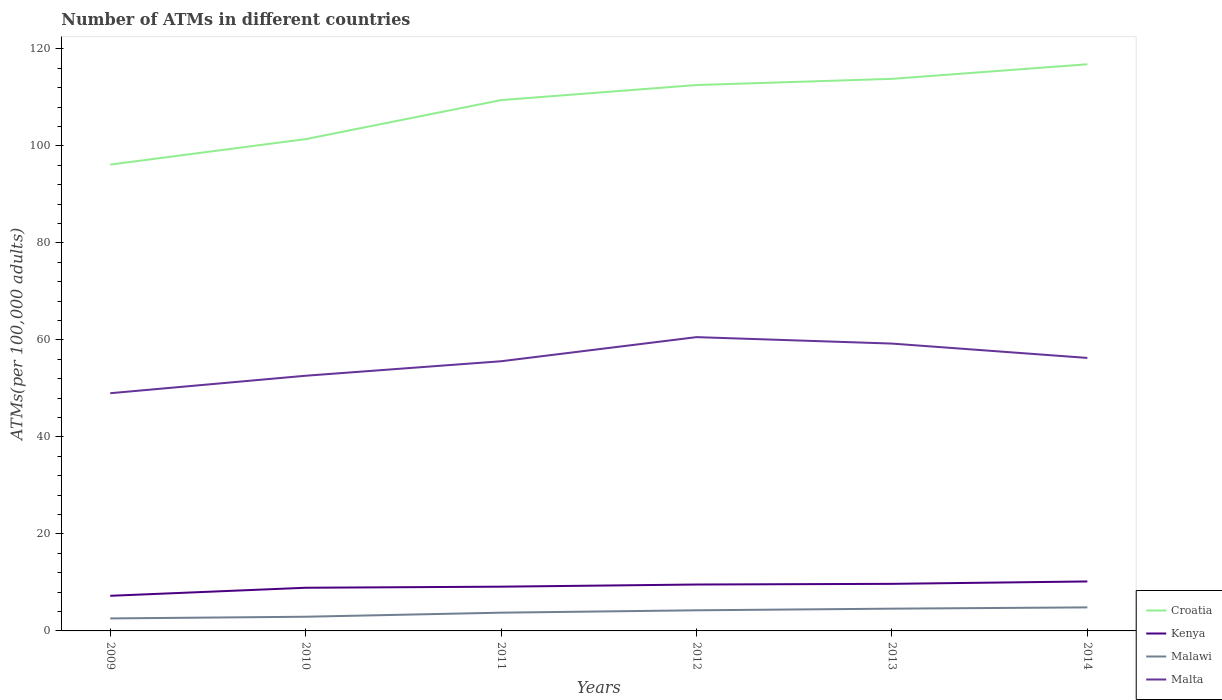Does the line corresponding to Kenya intersect with the line corresponding to Croatia?
Ensure brevity in your answer.  No. Across all years, what is the maximum number of ATMs in Croatia?
Your answer should be compact. 96.14. What is the total number of ATMs in Malawi in the graph?
Make the answer very short. -1.18. What is the difference between the highest and the second highest number of ATMs in Malta?
Keep it short and to the point. 11.56. Is the number of ATMs in Croatia strictly greater than the number of ATMs in Malawi over the years?
Provide a short and direct response. No. How many years are there in the graph?
Make the answer very short. 6. Are the values on the major ticks of Y-axis written in scientific E-notation?
Give a very brief answer. No. Does the graph contain grids?
Offer a terse response. No. How many legend labels are there?
Provide a succinct answer. 4. What is the title of the graph?
Provide a short and direct response. Number of ATMs in different countries. Does "South Sudan" appear as one of the legend labels in the graph?
Make the answer very short. No. What is the label or title of the Y-axis?
Your response must be concise. ATMs(per 100,0 adults). What is the ATMs(per 100,000 adults) in Croatia in 2009?
Your answer should be compact. 96.14. What is the ATMs(per 100,000 adults) of Kenya in 2009?
Offer a very short reply. 7.24. What is the ATMs(per 100,000 adults) in Malawi in 2009?
Keep it short and to the point. 2.58. What is the ATMs(per 100,000 adults) in Malta in 2009?
Offer a very short reply. 49.01. What is the ATMs(per 100,000 adults) in Croatia in 2010?
Give a very brief answer. 101.39. What is the ATMs(per 100,000 adults) of Kenya in 2010?
Provide a succinct answer. 8.9. What is the ATMs(per 100,000 adults) of Malawi in 2010?
Offer a terse response. 2.93. What is the ATMs(per 100,000 adults) of Malta in 2010?
Ensure brevity in your answer.  52.61. What is the ATMs(per 100,000 adults) of Croatia in 2011?
Make the answer very short. 109.44. What is the ATMs(per 100,000 adults) of Kenya in 2011?
Provide a short and direct response. 9.12. What is the ATMs(per 100,000 adults) of Malawi in 2011?
Provide a short and direct response. 3.76. What is the ATMs(per 100,000 adults) of Malta in 2011?
Provide a short and direct response. 55.6. What is the ATMs(per 100,000 adults) of Croatia in 2012?
Provide a short and direct response. 112.54. What is the ATMs(per 100,000 adults) in Kenya in 2012?
Give a very brief answer. 9.57. What is the ATMs(per 100,000 adults) of Malawi in 2012?
Give a very brief answer. 4.25. What is the ATMs(per 100,000 adults) of Malta in 2012?
Provide a succinct answer. 60.57. What is the ATMs(per 100,000 adults) of Croatia in 2013?
Keep it short and to the point. 113.82. What is the ATMs(per 100,000 adults) in Kenya in 2013?
Your answer should be very brief. 9.71. What is the ATMs(per 100,000 adults) of Malawi in 2013?
Ensure brevity in your answer.  4.59. What is the ATMs(per 100,000 adults) of Malta in 2013?
Provide a succinct answer. 59.24. What is the ATMs(per 100,000 adults) in Croatia in 2014?
Your response must be concise. 116.82. What is the ATMs(per 100,000 adults) of Kenya in 2014?
Your response must be concise. 10.2. What is the ATMs(per 100,000 adults) of Malawi in 2014?
Your answer should be compact. 4.85. What is the ATMs(per 100,000 adults) of Malta in 2014?
Keep it short and to the point. 56.28. Across all years, what is the maximum ATMs(per 100,000 adults) in Croatia?
Keep it short and to the point. 116.82. Across all years, what is the maximum ATMs(per 100,000 adults) of Kenya?
Your response must be concise. 10.2. Across all years, what is the maximum ATMs(per 100,000 adults) of Malawi?
Make the answer very short. 4.85. Across all years, what is the maximum ATMs(per 100,000 adults) of Malta?
Provide a short and direct response. 60.57. Across all years, what is the minimum ATMs(per 100,000 adults) of Croatia?
Provide a succinct answer. 96.14. Across all years, what is the minimum ATMs(per 100,000 adults) of Kenya?
Make the answer very short. 7.24. Across all years, what is the minimum ATMs(per 100,000 adults) of Malawi?
Your response must be concise. 2.58. Across all years, what is the minimum ATMs(per 100,000 adults) in Malta?
Give a very brief answer. 49.01. What is the total ATMs(per 100,000 adults) of Croatia in the graph?
Make the answer very short. 650.14. What is the total ATMs(per 100,000 adults) in Kenya in the graph?
Your answer should be very brief. 54.73. What is the total ATMs(per 100,000 adults) of Malawi in the graph?
Provide a short and direct response. 22.96. What is the total ATMs(per 100,000 adults) of Malta in the graph?
Ensure brevity in your answer.  333.3. What is the difference between the ATMs(per 100,000 adults) in Croatia in 2009 and that in 2010?
Make the answer very short. -5.25. What is the difference between the ATMs(per 100,000 adults) in Kenya in 2009 and that in 2010?
Provide a succinct answer. -1.66. What is the difference between the ATMs(per 100,000 adults) in Malawi in 2009 and that in 2010?
Provide a short and direct response. -0.35. What is the difference between the ATMs(per 100,000 adults) of Malta in 2009 and that in 2010?
Ensure brevity in your answer.  -3.6. What is the difference between the ATMs(per 100,000 adults) of Croatia in 2009 and that in 2011?
Offer a terse response. -13.3. What is the difference between the ATMs(per 100,000 adults) in Kenya in 2009 and that in 2011?
Your response must be concise. -1.88. What is the difference between the ATMs(per 100,000 adults) in Malawi in 2009 and that in 2011?
Give a very brief answer. -1.18. What is the difference between the ATMs(per 100,000 adults) in Malta in 2009 and that in 2011?
Ensure brevity in your answer.  -6.59. What is the difference between the ATMs(per 100,000 adults) in Croatia in 2009 and that in 2012?
Provide a short and direct response. -16.4. What is the difference between the ATMs(per 100,000 adults) in Kenya in 2009 and that in 2012?
Keep it short and to the point. -2.33. What is the difference between the ATMs(per 100,000 adults) of Malawi in 2009 and that in 2012?
Your answer should be compact. -1.68. What is the difference between the ATMs(per 100,000 adults) in Malta in 2009 and that in 2012?
Offer a terse response. -11.56. What is the difference between the ATMs(per 100,000 adults) of Croatia in 2009 and that in 2013?
Ensure brevity in your answer.  -17.68. What is the difference between the ATMs(per 100,000 adults) of Kenya in 2009 and that in 2013?
Make the answer very short. -2.46. What is the difference between the ATMs(per 100,000 adults) of Malawi in 2009 and that in 2013?
Ensure brevity in your answer.  -2.01. What is the difference between the ATMs(per 100,000 adults) of Malta in 2009 and that in 2013?
Offer a very short reply. -10.23. What is the difference between the ATMs(per 100,000 adults) in Croatia in 2009 and that in 2014?
Keep it short and to the point. -20.68. What is the difference between the ATMs(per 100,000 adults) of Kenya in 2009 and that in 2014?
Offer a terse response. -2.96. What is the difference between the ATMs(per 100,000 adults) in Malawi in 2009 and that in 2014?
Keep it short and to the point. -2.28. What is the difference between the ATMs(per 100,000 adults) of Malta in 2009 and that in 2014?
Keep it short and to the point. -7.27. What is the difference between the ATMs(per 100,000 adults) of Croatia in 2010 and that in 2011?
Ensure brevity in your answer.  -8.05. What is the difference between the ATMs(per 100,000 adults) of Kenya in 2010 and that in 2011?
Offer a very short reply. -0.22. What is the difference between the ATMs(per 100,000 adults) of Malawi in 2010 and that in 2011?
Provide a short and direct response. -0.84. What is the difference between the ATMs(per 100,000 adults) of Malta in 2010 and that in 2011?
Provide a short and direct response. -2.99. What is the difference between the ATMs(per 100,000 adults) of Croatia in 2010 and that in 2012?
Make the answer very short. -11.15. What is the difference between the ATMs(per 100,000 adults) of Kenya in 2010 and that in 2012?
Give a very brief answer. -0.67. What is the difference between the ATMs(per 100,000 adults) of Malawi in 2010 and that in 2012?
Offer a very short reply. -1.33. What is the difference between the ATMs(per 100,000 adults) of Malta in 2010 and that in 2012?
Keep it short and to the point. -7.96. What is the difference between the ATMs(per 100,000 adults) in Croatia in 2010 and that in 2013?
Keep it short and to the point. -12.43. What is the difference between the ATMs(per 100,000 adults) in Kenya in 2010 and that in 2013?
Give a very brief answer. -0.81. What is the difference between the ATMs(per 100,000 adults) in Malawi in 2010 and that in 2013?
Provide a succinct answer. -1.67. What is the difference between the ATMs(per 100,000 adults) in Malta in 2010 and that in 2013?
Your response must be concise. -6.63. What is the difference between the ATMs(per 100,000 adults) of Croatia in 2010 and that in 2014?
Ensure brevity in your answer.  -15.43. What is the difference between the ATMs(per 100,000 adults) of Kenya in 2010 and that in 2014?
Make the answer very short. -1.3. What is the difference between the ATMs(per 100,000 adults) in Malawi in 2010 and that in 2014?
Provide a short and direct response. -1.93. What is the difference between the ATMs(per 100,000 adults) of Malta in 2010 and that in 2014?
Your answer should be very brief. -3.67. What is the difference between the ATMs(per 100,000 adults) of Croatia in 2011 and that in 2012?
Offer a terse response. -3.1. What is the difference between the ATMs(per 100,000 adults) of Kenya in 2011 and that in 2012?
Your answer should be compact. -0.45. What is the difference between the ATMs(per 100,000 adults) of Malawi in 2011 and that in 2012?
Provide a short and direct response. -0.49. What is the difference between the ATMs(per 100,000 adults) of Malta in 2011 and that in 2012?
Offer a very short reply. -4.97. What is the difference between the ATMs(per 100,000 adults) of Croatia in 2011 and that in 2013?
Ensure brevity in your answer.  -4.38. What is the difference between the ATMs(per 100,000 adults) in Kenya in 2011 and that in 2013?
Make the answer very short. -0.58. What is the difference between the ATMs(per 100,000 adults) of Malawi in 2011 and that in 2013?
Provide a short and direct response. -0.83. What is the difference between the ATMs(per 100,000 adults) in Malta in 2011 and that in 2013?
Provide a short and direct response. -3.64. What is the difference between the ATMs(per 100,000 adults) of Croatia in 2011 and that in 2014?
Your response must be concise. -7.38. What is the difference between the ATMs(per 100,000 adults) in Kenya in 2011 and that in 2014?
Offer a very short reply. -1.08. What is the difference between the ATMs(per 100,000 adults) of Malawi in 2011 and that in 2014?
Your response must be concise. -1.09. What is the difference between the ATMs(per 100,000 adults) in Malta in 2011 and that in 2014?
Provide a succinct answer. -0.68. What is the difference between the ATMs(per 100,000 adults) of Croatia in 2012 and that in 2013?
Make the answer very short. -1.28. What is the difference between the ATMs(per 100,000 adults) in Kenya in 2012 and that in 2013?
Provide a short and direct response. -0.14. What is the difference between the ATMs(per 100,000 adults) of Malawi in 2012 and that in 2013?
Your answer should be very brief. -0.34. What is the difference between the ATMs(per 100,000 adults) of Malta in 2012 and that in 2013?
Your answer should be very brief. 1.33. What is the difference between the ATMs(per 100,000 adults) of Croatia in 2012 and that in 2014?
Offer a terse response. -4.28. What is the difference between the ATMs(per 100,000 adults) of Kenya in 2012 and that in 2014?
Ensure brevity in your answer.  -0.63. What is the difference between the ATMs(per 100,000 adults) in Malawi in 2012 and that in 2014?
Provide a succinct answer. -0.6. What is the difference between the ATMs(per 100,000 adults) of Malta in 2012 and that in 2014?
Offer a terse response. 4.29. What is the difference between the ATMs(per 100,000 adults) in Croatia in 2013 and that in 2014?
Provide a short and direct response. -3. What is the difference between the ATMs(per 100,000 adults) in Kenya in 2013 and that in 2014?
Make the answer very short. -0.49. What is the difference between the ATMs(per 100,000 adults) of Malawi in 2013 and that in 2014?
Give a very brief answer. -0.26. What is the difference between the ATMs(per 100,000 adults) in Malta in 2013 and that in 2014?
Provide a succinct answer. 2.96. What is the difference between the ATMs(per 100,000 adults) of Croatia in 2009 and the ATMs(per 100,000 adults) of Kenya in 2010?
Provide a succinct answer. 87.24. What is the difference between the ATMs(per 100,000 adults) in Croatia in 2009 and the ATMs(per 100,000 adults) in Malawi in 2010?
Your response must be concise. 93.21. What is the difference between the ATMs(per 100,000 adults) of Croatia in 2009 and the ATMs(per 100,000 adults) of Malta in 2010?
Offer a terse response. 43.53. What is the difference between the ATMs(per 100,000 adults) in Kenya in 2009 and the ATMs(per 100,000 adults) in Malawi in 2010?
Offer a terse response. 4.32. What is the difference between the ATMs(per 100,000 adults) of Kenya in 2009 and the ATMs(per 100,000 adults) of Malta in 2010?
Offer a very short reply. -45.37. What is the difference between the ATMs(per 100,000 adults) in Malawi in 2009 and the ATMs(per 100,000 adults) in Malta in 2010?
Your answer should be very brief. -50.03. What is the difference between the ATMs(per 100,000 adults) of Croatia in 2009 and the ATMs(per 100,000 adults) of Kenya in 2011?
Offer a terse response. 87.02. What is the difference between the ATMs(per 100,000 adults) of Croatia in 2009 and the ATMs(per 100,000 adults) of Malawi in 2011?
Offer a terse response. 92.38. What is the difference between the ATMs(per 100,000 adults) of Croatia in 2009 and the ATMs(per 100,000 adults) of Malta in 2011?
Offer a terse response. 40.54. What is the difference between the ATMs(per 100,000 adults) of Kenya in 2009 and the ATMs(per 100,000 adults) of Malawi in 2011?
Give a very brief answer. 3.48. What is the difference between the ATMs(per 100,000 adults) in Kenya in 2009 and the ATMs(per 100,000 adults) in Malta in 2011?
Make the answer very short. -48.36. What is the difference between the ATMs(per 100,000 adults) in Malawi in 2009 and the ATMs(per 100,000 adults) in Malta in 2011?
Your answer should be compact. -53.02. What is the difference between the ATMs(per 100,000 adults) in Croatia in 2009 and the ATMs(per 100,000 adults) in Kenya in 2012?
Your response must be concise. 86.57. What is the difference between the ATMs(per 100,000 adults) of Croatia in 2009 and the ATMs(per 100,000 adults) of Malawi in 2012?
Your response must be concise. 91.89. What is the difference between the ATMs(per 100,000 adults) in Croatia in 2009 and the ATMs(per 100,000 adults) in Malta in 2012?
Your answer should be very brief. 35.57. What is the difference between the ATMs(per 100,000 adults) in Kenya in 2009 and the ATMs(per 100,000 adults) in Malawi in 2012?
Ensure brevity in your answer.  2.99. What is the difference between the ATMs(per 100,000 adults) in Kenya in 2009 and the ATMs(per 100,000 adults) in Malta in 2012?
Provide a succinct answer. -53.33. What is the difference between the ATMs(per 100,000 adults) of Malawi in 2009 and the ATMs(per 100,000 adults) of Malta in 2012?
Provide a succinct answer. -57.99. What is the difference between the ATMs(per 100,000 adults) in Croatia in 2009 and the ATMs(per 100,000 adults) in Kenya in 2013?
Your answer should be very brief. 86.43. What is the difference between the ATMs(per 100,000 adults) of Croatia in 2009 and the ATMs(per 100,000 adults) of Malawi in 2013?
Give a very brief answer. 91.55. What is the difference between the ATMs(per 100,000 adults) of Croatia in 2009 and the ATMs(per 100,000 adults) of Malta in 2013?
Offer a very short reply. 36.9. What is the difference between the ATMs(per 100,000 adults) in Kenya in 2009 and the ATMs(per 100,000 adults) in Malawi in 2013?
Offer a terse response. 2.65. What is the difference between the ATMs(per 100,000 adults) in Kenya in 2009 and the ATMs(per 100,000 adults) in Malta in 2013?
Keep it short and to the point. -52. What is the difference between the ATMs(per 100,000 adults) in Malawi in 2009 and the ATMs(per 100,000 adults) in Malta in 2013?
Your answer should be very brief. -56.66. What is the difference between the ATMs(per 100,000 adults) of Croatia in 2009 and the ATMs(per 100,000 adults) of Kenya in 2014?
Keep it short and to the point. 85.94. What is the difference between the ATMs(per 100,000 adults) in Croatia in 2009 and the ATMs(per 100,000 adults) in Malawi in 2014?
Provide a short and direct response. 91.29. What is the difference between the ATMs(per 100,000 adults) of Croatia in 2009 and the ATMs(per 100,000 adults) of Malta in 2014?
Ensure brevity in your answer.  39.86. What is the difference between the ATMs(per 100,000 adults) in Kenya in 2009 and the ATMs(per 100,000 adults) in Malawi in 2014?
Your response must be concise. 2.39. What is the difference between the ATMs(per 100,000 adults) of Kenya in 2009 and the ATMs(per 100,000 adults) of Malta in 2014?
Offer a very short reply. -49.04. What is the difference between the ATMs(per 100,000 adults) in Malawi in 2009 and the ATMs(per 100,000 adults) in Malta in 2014?
Your answer should be very brief. -53.71. What is the difference between the ATMs(per 100,000 adults) of Croatia in 2010 and the ATMs(per 100,000 adults) of Kenya in 2011?
Keep it short and to the point. 92.27. What is the difference between the ATMs(per 100,000 adults) in Croatia in 2010 and the ATMs(per 100,000 adults) in Malawi in 2011?
Offer a terse response. 97.63. What is the difference between the ATMs(per 100,000 adults) of Croatia in 2010 and the ATMs(per 100,000 adults) of Malta in 2011?
Your answer should be very brief. 45.79. What is the difference between the ATMs(per 100,000 adults) in Kenya in 2010 and the ATMs(per 100,000 adults) in Malawi in 2011?
Provide a short and direct response. 5.14. What is the difference between the ATMs(per 100,000 adults) of Kenya in 2010 and the ATMs(per 100,000 adults) of Malta in 2011?
Provide a short and direct response. -46.7. What is the difference between the ATMs(per 100,000 adults) of Malawi in 2010 and the ATMs(per 100,000 adults) of Malta in 2011?
Ensure brevity in your answer.  -52.67. What is the difference between the ATMs(per 100,000 adults) of Croatia in 2010 and the ATMs(per 100,000 adults) of Kenya in 2012?
Keep it short and to the point. 91.82. What is the difference between the ATMs(per 100,000 adults) of Croatia in 2010 and the ATMs(per 100,000 adults) of Malawi in 2012?
Provide a short and direct response. 97.14. What is the difference between the ATMs(per 100,000 adults) of Croatia in 2010 and the ATMs(per 100,000 adults) of Malta in 2012?
Ensure brevity in your answer.  40.82. What is the difference between the ATMs(per 100,000 adults) of Kenya in 2010 and the ATMs(per 100,000 adults) of Malawi in 2012?
Provide a succinct answer. 4.65. What is the difference between the ATMs(per 100,000 adults) in Kenya in 2010 and the ATMs(per 100,000 adults) in Malta in 2012?
Your answer should be compact. -51.67. What is the difference between the ATMs(per 100,000 adults) of Malawi in 2010 and the ATMs(per 100,000 adults) of Malta in 2012?
Make the answer very short. -57.64. What is the difference between the ATMs(per 100,000 adults) of Croatia in 2010 and the ATMs(per 100,000 adults) of Kenya in 2013?
Ensure brevity in your answer.  91.68. What is the difference between the ATMs(per 100,000 adults) of Croatia in 2010 and the ATMs(per 100,000 adults) of Malawi in 2013?
Provide a short and direct response. 96.8. What is the difference between the ATMs(per 100,000 adults) in Croatia in 2010 and the ATMs(per 100,000 adults) in Malta in 2013?
Your response must be concise. 42.15. What is the difference between the ATMs(per 100,000 adults) in Kenya in 2010 and the ATMs(per 100,000 adults) in Malawi in 2013?
Offer a very short reply. 4.31. What is the difference between the ATMs(per 100,000 adults) in Kenya in 2010 and the ATMs(per 100,000 adults) in Malta in 2013?
Ensure brevity in your answer.  -50.34. What is the difference between the ATMs(per 100,000 adults) in Malawi in 2010 and the ATMs(per 100,000 adults) in Malta in 2013?
Keep it short and to the point. -56.31. What is the difference between the ATMs(per 100,000 adults) in Croatia in 2010 and the ATMs(per 100,000 adults) in Kenya in 2014?
Keep it short and to the point. 91.19. What is the difference between the ATMs(per 100,000 adults) of Croatia in 2010 and the ATMs(per 100,000 adults) of Malawi in 2014?
Offer a very short reply. 96.54. What is the difference between the ATMs(per 100,000 adults) in Croatia in 2010 and the ATMs(per 100,000 adults) in Malta in 2014?
Ensure brevity in your answer.  45.11. What is the difference between the ATMs(per 100,000 adults) of Kenya in 2010 and the ATMs(per 100,000 adults) of Malawi in 2014?
Ensure brevity in your answer.  4.05. What is the difference between the ATMs(per 100,000 adults) of Kenya in 2010 and the ATMs(per 100,000 adults) of Malta in 2014?
Provide a short and direct response. -47.38. What is the difference between the ATMs(per 100,000 adults) of Malawi in 2010 and the ATMs(per 100,000 adults) of Malta in 2014?
Your response must be concise. -53.36. What is the difference between the ATMs(per 100,000 adults) in Croatia in 2011 and the ATMs(per 100,000 adults) in Kenya in 2012?
Keep it short and to the point. 99.87. What is the difference between the ATMs(per 100,000 adults) of Croatia in 2011 and the ATMs(per 100,000 adults) of Malawi in 2012?
Ensure brevity in your answer.  105.18. What is the difference between the ATMs(per 100,000 adults) of Croatia in 2011 and the ATMs(per 100,000 adults) of Malta in 2012?
Offer a terse response. 48.87. What is the difference between the ATMs(per 100,000 adults) of Kenya in 2011 and the ATMs(per 100,000 adults) of Malawi in 2012?
Keep it short and to the point. 4.87. What is the difference between the ATMs(per 100,000 adults) of Kenya in 2011 and the ATMs(per 100,000 adults) of Malta in 2012?
Make the answer very short. -51.45. What is the difference between the ATMs(per 100,000 adults) of Malawi in 2011 and the ATMs(per 100,000 adults) of Malta in 2012?
Offer a terse response. -56.81. What is the difference between the ATMs(per 100,000 adults) in Croatia in 2011 and the ATMs(per 100,000 adults) in Kenya in 2013?
Offer a terse response. 99.73. What is the difference between the ATMs(per 100,000 adults) in Croatia in 2011 and the ATMs(per 100,000 adults) in Malawi in 2013?
Your answer should be compact. 104.85. What is the difference between the ATMs(per 100,000 adults) in Croatia in 2011 and the ATMs(per 100,000 adults) in Malta in 2013?
Provide a succinct answer. 50.2. What is the difference between the ATMs(per 100,000 adults) of Kenya in 2011 and the ATMs(per 100,000 adults) of Malawi in 2013?
Offer a very short reply. 4.53. What is the difference between the ATMs(per 100,000 adults) in Kenya in 2011 and the ATMs(per 100,000 adults) in Malta in 2013?
Your answer should be very brief. -50.12. What is the difference between the ATMs(per 100,000 adults) in Malawi in 2011 and the ATMs(per 100,000 adults) in Malta in 2013?
Your answer should be compact. -55.48. What is the difference between the ATMs(per 100,000 adults) of Croatia in 2011 and the ATMs(per 100,000 adults) of Kenya in 2014?
Give a very brief answer. 99.24. What is the difference between the ATMs(per 100,000 adults) in Croatia in 2011 and the ATMs(per 100,000 adults) in Malawi in 2014?
Give a very brief answer. 104.58. What is the difference between the ATMs(per 100,000 adults) of Croatia in 2011 and the ATMs(per 100,000 adults) of Malta in 2014?
Provide a succinct answer. 53.15. What is the difference between the ATMs(per 100,000 adults) of Kenya in 2011 and the ATMs(per 100,000 adults) of Malawi in 2014?
Your answer should be very brief. 4.27. What is the difference between the ATMs(per 100,000 adults) in Kenya in 2011 and the ATMs(per 100,000 adults) in Malta in 2014?
Offer a very short reply. -47.16. What is the difference between the ATMs(per 100,000 adults) in Malawi in 2011 and the ATMs(per 100,000 adults) in Malta in 2014?
Ensure brevity in your answer.  -52.52. What is the difference between the ATMs(per 100,000 adults) of Croatia in 2012 and the ATMs(per 100,000 adults) of Kenya in 2013?
Ensure brevity in your answer.  102.83. What is the difference between the ATMs(per 100,000 adults) in Croatia in 2012 and the ATMs(per 100,000 adults) in Malawi in 2013?
Your answer should be very brief. 107.95. What is the difference between the ATMs(per 100,000 adults) in Croatia in 2012 and the ATMs(per 100,000 adults) in Malta in 2013?
Offer a very short reply. 53.3. What is the difference between the ATMs(per 100,000 adults) in Kenya in 2012 and the ATMs(per 100,000 adults) in Malawi in 2013?
Ensure brevity in your answer.  4.98. What is the difference between the ATMs(per 100,000 adults) of Kenya in 2012 and the ATMs(per 100,000 adults) of Malta in 2013?
Your answer should be very brief. -49.67. What is the difference between the ATMs(per 100,000 adults) of Malawi in 2012 and the ATMs(per 100,000 adults) of Malta in 2013?
Offer a terse response. -54.99. What is the difference between the ATMs(per 100,000 adults) of Croatia in 2012 and the ATMs(per 100,000 adults) of Kenya in 2014?
Your answer should be compact. 102.34. What is the difference between the ATMs(per 100,000 adults) of Croatia in 2012 and the ATMs(per 100,000 adults) of Malawi in 2014?
Your answer should be very brief. 107.69. What is the difference between the ATMs(per 100,000 adults) of Croatia in 2012 and the ATMs(per 100,000 adults) of Malta in 2014?
Offer a terse response. 56.26. What is the difference between the ATMs(per 100,000 adults) in Kenya in 2012 and the ATMs(per 100,000 adults) in Malawi in 2014?
Your answer should be compact. 4.72. What is the difference between the ATMs(per 100,000 adults) of Kenya in 2012 and the ATMs(per 100,000 adults) of Malta in 2014?
Provide a short and direct response. -46.71. What is the difference between the ATMs(per 100,000 adults) in Malawi in 2012 and the ATMs(per 100,000 adults) in Malta in 2014?
Your answer should be compact. -52.03. What is the difference between the ATMs(per 100,000 adults) of Croatia in 2013 and the ATMs(per 100,000 adults) of Kenya in 2014?
Make the answer very short. 103.62. What is the difference between the ATMs(per 100,000 adults) in Croatia in 2013 and the ATMs(per 100,000 adults) in Malawi in 2014?
Give a very brief answer. 108.97. What is the difference between the ATMs(per 100,000 adults) in Croatia in 2013 and the ATMs(per 100,000 adults) in Malta in 2014?
Your response must be concise. 57.54. What is the difference between the ATMs(per 100,000 adults) in Kenya in 2013 and the ATMs(per 100,000 adults) in Malawi in 2014?
Offer a terse response. 4.85. What is the difference between the ATMs(per 100,000 adults) in Kenya in 2013 and the ATMs(per 100,000 adults) in Malta in 2014?
Offer a very short reply. -46.58. What is the difference between the ATMs(per 100,000 adults) of Malawi in 2013 and the ATMs(per 100,000 adults) of Malta in 2014?
Provide a succinct answer. -51.69. What is the average ATMs(per 100,000 adults) of Croatia per year?
Keep it short and to the point. 108.36. What is the average ATMs(per 100,000 adults) of Kenya per year?
Make the answer very short. 9.12. What is the average ATMs(per 100,000 adults) of Malawi per year?
Give a very brief answer. 3.83. What is the average ATMs(per 100,000 adults) of Malta per year?
Ensure brevity in your answer.  55.55. In the year 2009, what is the difference between the ATMs(per 100,000 adults) of Croatia and ATMs(per 100,000 adults) of Kenya?
Offer a very short reply. 88.9. In the year 2009, what is the difference between the ATMs(per 100,000 adults) of Croatia and ATMs(per 100,000 adults) of Malawi?
Your answer should be compact. 93.56. In the year 2009, what is the difference between the ATMs(per 100,000 adults) in Croatia and ATMs(per 100,000 adults) in Malta?
Make the answer very short. 47.13. In the year 2009, what is the difference between the ATMs(per 100,000 adults) of Kenya and ATMs(per 100,000 adults) of Malawi?
Ensure brevity in your answer.  4.67. In the year 2009, what is the difference between the ATMs(per 100,000 adults) in Kenya and ATMs(per 100,000 adults) in Malta?
Keep it short and to the point. -41.77. In the year 2009, what is the difference between the ATMs(per 100,000 adults) in Malawi and ATMs(per 100,000 adults) in Malta?
Provide a short and direct response. -46.43. In the year 2010, what is the difference between the ATMs(per 100,000 adults) in Croatia and ATMs(per 100,000 adults) in Kenya?
Offer a terse response. 92.49. In the year 2010, what is the difference between the ATMs(per 100,000 adults) in Croatia and ATMs(per 100,000 adults) in Malawi?
Provide a short and direct response. 98.46. In the year 2010, what is the difference between the ATMs(per 100,000 adults) in Croatia and ATMs(per 100,000 adults) in Malta?
Provide a short and direct response. 48.78. In the year 2010, what is the difference between the ATMs(per 100,000 adults) of Kenya and ATMs(per 100,000 adults) of Malawi?
Provide a succinct answer. 5.97. In the year 2010, what is the difference between the ATMs(per 100,000 adults) of Kenya and ATMs(per 100,000 adults) of Malta?
Your answer should be compact. -43.71. In the year 2010, what is the difference between the ATMs(per 100,000 adults) of Malawi and ATMs(per 100,000 adults) of Malta?
Your response must be concise. -49.68. In the year 2011, what is the difference between the ATMs(per 100,000 adults) of Croatia and ATMs(per 100,000 adults) of Kenya?
Offer a terse response. 100.31. In the year 2011, what is the difference between the ATMs(per 100,000 adults) of Croatia and ATMs(per 100,000 adults) of Malawi?
Provide a succinct answer. 105.68. In the year 2011, what is the difference between the ATMs(per 100,000 adults) of Croatia and ATMs(per 100,000 adults) of Malta?
Provide a succinct answer. 53.84. In the year 2011, what is the difference between the ATMs(per 100,000 adults) of Kenya and ATMs(per 100,000 adults) of Malawi?
Provide a short and direct response. 5.36. In the year 2011, what is the difference between the ATMs(per 100,000 adults) in Kenya and ATMs(per 100,000 adults) in Malta?
Provide a succinct answer. -46.48. In the year 2011, what is the difference between the ATMs(per 100,000 adults) of Malawi and ATMs(per 100,000 adults) of Malta?
Your response must be concise. -51.84. In the year 2012, what is the difference between the ATMs(per 100,000 adults) of Croatia and ATMs(per 100,000 adults) of Kenya?
Give a very brief answer. 102.97. In the year 2012, what is the difference between the ATMs(per 100,000 adults) of Croatia and ATMs(per 100,000 adults) of Malawi?
Provide a succinct answer. 108.29. In the year 2012, what is the difference between the ATMs(per 100,000 adults) of Croatia and ATMs(per 100,000 adults) of Malta?
Offer a terse response. 51.97. In the year 2012, what is the difference between the ATMs(per 100,000 adults) of Kenya and ATMs(per 100,000 adults) of Malawi?
Your response must be concise. 5.32. In the year 2012, what is the difference between the ATMs(per 100,000 adults) of Kenya and ATMs(per 100,000 adults) of Malta?
Provide a succinct answer. -51. In the year 2012, what is the difference between the ATMs(per 100,000 adults) in Malawi and ATMs(per 100,000 adults) in Malta?
Keep it short and to the point. -56.32. In the year 2013, what is the difference between the ATMs(per 100,000 adults) in Croatia and ATMs(per 100,000 adults) in Kenya?
Offer a terse response. 104.11. In the year 2013, what is the difference between the ATMs(per 100,000 adults) of Croatia and ATMs(per 100,000 adults) of Malawi?
Your answer should be very brief. 109.23. In the year 2013, what is the difference between the ATMs(per 100,000 adults) of Croatia and ATMs(per 100,000 adults) of Malta?
Provide a short and direct response. 54.58. In the year 2013, what is the difference between the ATMs(per 100,000 adults) in Kenya and ATMs(per 100,000 adults) in Malawi?
Your response must be concise. 5.11. In the year 2013, what is the difference between the ATMs(per 100,000 adults) in Kenya and ATMs(per 100,000 adults) in Malta?
Make the answer very short. -49.53. In the year 2013, what is the difference between the ATMs(per 100,000 adults) of Malawi and ATMs(per 100,000 adults) of Malta?
Provide a short and direct response. -54.65. In the year 2014, what is the difference between the ATMs(per 100,000 adults) of Croatia and ATMs(per 100,000 adults) of Kenya?
Ensure brevity in your answer.  106.62. In the year 2014, what is the difference between the ATMs(per 100,000 adults) of Croatia and ATMs(per 100,000 adults) of Malawi?
Offer a very short reply. 111.97. In the year 2014, what is the difference between the ATMs(per 100,000 adults) in Croatia and ATMs(per 100,000 adults) in Malta?
Offer a terse response. 60.54. In the year 2014, what is the difference between the ATMs(per 100,000 adults) of Kenya and ATMs(per 100,000 adults) of Malawi?
Ensure brevity in your answer.  5.34. In the year 2014, what is the difference between the ATMs(per 100,000 adults) in Kenya and ATMs(per 100,000 adults) in Malta?
Your answer should be very brief. -46.08. In the year 2014, what is the difference between the ATMs(per 100,000 adults) of Malawi and ATMs(per 100,000 adults) of Malta?
Your answer should be compact. -51.43. What is the ratio of the ATMs(per 100,000 adults) of Croatia in 2009 to that in 2010?
Provide a succinct answer. 0.95. What is the ratio of the ATMs(per 100,000 adults) in Kenya in 2009 to that in 2010?
Make the answer very short. 0.81. What is the ratio of the ATMs(per 100,000 adults) in Malawi in 2009 to that in 2010?
Ensure brevity in your answer.  0.88. What is the ratio of the ATMs(per 100,000 adults) in Malta in 2009 to that in 2010?
Offer a terse response. 0.93. What is the ratio of the ATMs(per 100,000 adults) of Croatia in 2009 to that in 2011?
Your answer should be very brief. 0.88. What is the ratio of the ATMs(per 100,000 adults) in Kenya in 2009 to that in 2011?
Offer a very short reply. 0.79. What is the ratio of the ATMs(per 100,000 adults) in Malawi in 2009 to that in 2011?
Offer a terse response. 0.69. What is the ratio of the ATMs(per 100,000 adults) in Malta in 2009 to that in 2011?
Your response must be concise. 0.88. What is the ratio of the ATMs(per 100,000 adults) of Croatia in 2009 to that in 2012?
Offer a terse response. 0.85. What is the ratio of the ATMs(per 100,000 adults) of Kenya in 2009 to that in 2012?
Provide a short and direct response. 0.76. What is the ratio of the ATMs(per 100,000 adults) of Malawi in 2009 to that in 2012?
Offer a terse response. 0.61. What is the ratio of the ATMs(per 100,000 adults) of Malta in 2009 to that in 2012?
Ensure brevity in your answer.  0.81. What is the ratio of the ATMs(per 100,000 adults) in Croatia in 2009 to that in 2013?
Give a very brief answer. 0.84. What is the ratio of the ATMs(per 100,000 adults) in Kenya in 2009 to that in 2013?
Provide a short and direct response. 0.75. What is the ratio of the ATMs(per 100,000 adults) in Malawi in 2009 to that in 2013?
Offer a very short reply. 0.56. What is the ratio of the ATMs(per 100,000 adults) in Malta in 2009 to that in 2013?
Your answer should be compact. 0.83. What is the ratio of the ATMs(per 100,000 adults) of Croatia in 2009 to that in 2014?
Ensure brevity in your answer.  0.82. What is the ratio of the ATMs(per 100,000 adults) in Kenya in 2009 to that in 2014?
Your answer should be very brief. 0.71. What is the ratio of the ATMs(per 100,000 adults) in Malawi in 2009 to that in 2014?
Your answer should be compact. 0.53. What is the ratio of the ATMs(per 100,000 adults) in Malta in 2009 to that in 2014?
Make the answer very short. 0.87. What is the ratio of the ATMs(per 100,000 adults) of Croatia in 2010 to that in 2011?
Make the answer very short. 0.93. What is the ratio of the ATMs(per 100,000 adults) in Kenya in 2010 to that in 2011?
Your response must be concise. 0.98. What is the ratio of the ATMs(per 100,000 adults) of Malta in 2010 to that in 2011?
Ensure brevity in your answer.  0.95. What is the ratio of the ATMs(per 100,000 adults) in Croatia in 2010 to that in 2012?
Make the answer very short. 0.9. What is the ratio of the ATMs(per 100,000 adults) of Kenya in 2010 to that in 2012?
Your answer should be compact. 0.93. What is the ratio of the ATMs(per 100,000 adults) in Malawi in 2010 to that in 2012?
Provide a succinct answer. 0.69. What is the ratio of the ATMs(per 100,000 adults) of Malta in 2010 to that in 2012?
Offer a very short reply. 0.87. What is the ratio of the ATMs(per 100,000 adults) in Croatia in 2010 to that in 2013?
Make the answer very short. 0.89. What is the ratio of the ATMs(per 100,000 adults) in Kenya in 2010 to that in 2013?
Your response must be concise. 0.92. What is the ratio of the ATMs(per 100,000 adults) in Malawi in 2010 to that in 2013?
Provide a short and direct response. 0.64. What is the ratio of the ATMs(per 100,000 adults) of Malta in 2010 to that in 2013?
Ensure brevity in your answer.  0.89. What is the ratio of the ATMs(per 100,000 adults) of Croatia in 2010 to that in 2014?
Provide a succinct answer. 0.87. What is the ratio of the ATMs(per 100,000 adults) of Kenya in 2010 to that in 2014?
Make the answer very short. 0.87. What is the ratio of the ATMs(per 100,000 adults) of Malawi in 2010 to that in 2014?
Your answer should be compact. 0.6. What is the ratio of the ATMs(per 100,000 adults) in Malta in 2010 to that in 2014?
Your answer should be very brief. 0.93. What is the ratio of the ATMs(per 100,000 adults) of Croatia in 2011 to that in 2012?
Your answer should be very brief. 0.97. What is the ratio of the ATMs(per 100,000 adults) of Kenya in 2011 to that in 2012?
Provide a short and direct response. 0.95. What is the ratio of the ATMs(per 100,000 adults) of Malawi in 2011 to that in 2012?
Give a very brief answer. 0.88. What is the ratio of the ATMs(per 100,000 adults) of Malta in 2011 to that in 2012?
Provide a succinct answer. 0.92. What is the ratio of the ATMs(per 100,000 adults) in Croatia in 2011 to that in 2013?
Your answer should be very brief. 0.96. What is the ratio of the ATMs(per 100,000 adults) of Kenya in 2011 to that in 2013?
Your response must be concise. 0.94. What is the ratio of the ATMs(per 100,000 adults) in Malawi in 2011 to that in 2013?
Your answer should be compact. 0.82. What is the ratio of the ATMs(per 100,000 adults) in Malta in 2011 to that in 2013?
Provide a succinct answer. 0.94. What is the ratio of the ATMs(per 100,000 adults) in Croatia in 2011 to that in 2014?
Offer a terse response. 0.94. What is the ratio of the ATMs(per 100,000 adults) in Kenya in 2011 to that in 2014?
Offer a terse response. 0.89. What is the ratio of the ATMs(per 100,000 adults) in Malawi in 2011 to that in 2014?
Offer a terse response. 0.78. What is the ratio of the ATMs(per 100,000 adults) of Malta in 2011 to that in 2014?
Provide a succinct answer. 0.99. What is the ratio of the ATMs(per 100,000 adults) of Croatia in 2012 to that in 2013?
Offer a terse response. 0.99. What is the ratio of the ATMs(per 100,000 adults) in Kenya in 2012 to that in 2013?
Ensure brevity in your answer.  0.99. What is the ratio of the ATMs(per 100,000 adults) of Malawi in 2012 to that in 2013?
Make the answer very short. 0.93. What is the ratio of the ATMs(per 100,000 adults) in Malta in 2012 to that in 2013?
Keep it short and to the point. 1.02. What is the ratio of the ATMs(per 100,000 adults) in Croatia in 2012 to that in 2014?
Provide a short and direct response. 0.96. What is the ratio of the ATMs(per 100,000 adults) in Kenya in 2012 to that in 2014?
Offer a terse response. 0.94. What is the ratio of the ATMs(per 100,000 adults) of Malawi in 2012 to that in 2014?
Provide a succinct answer. 0.88. What is the ratio of the ATMs(per 100,000 adults) of Malta in 2012 to that in 2014?
Offer a terse response. 1.08. What is the ratio of the ATMs(per 100,000 adults) in Croatia in 2013 to that in 2014?
Provide a succinct answer. 0.97. What is the ratio of the ATMs(per 100,000 adults) of Kenya in 2013 to that in 2014?
Your answer should be very brief. 0.95. What is the ratio of the ATMs(per 100,000 adults) in Malawi in 2013 to that in 2014?
Your answer should be compact. 0.95. What is the ratio of the ATMs(per 100,000 adults) of Malta in 2013 to that in 2014?
Your response must be concise. 1.05. What is the difference between the highest and the second highest ATMs(per 100,000 adults) in Croatia?
Your answer should be very brief. 3. What is the difference between the highest and the second highest ATMs(per 100,000 adults) of Kenya?
Make the answer very short. 0.49. What is the difference between the highest and the second highest ATMs(per 100,000 adults) in Malawi?
Ensure brevity in your answer.  0.26. What is the difference between the highest and the second highest ATMs(per 100,000 adults) of Malta?
Offer a very short reply. 1.33. What is the difference between the highest and the lowest ATMs(per 100,000 adults) of Croatia?
Provide a short and direct response. 20.68. What is the difference between the highest and the lowest ATMs(per 100,000 adults) in Kenya?
Keep it short and to the point. 2.96. What is the difference between the highest and the lowest ATMs(per 100,000 adults) of Malawi?
Provide a short and direct response. 2.28. What is the difference between the highest and the lowest ATMs(per 100,000 adults) of Malta?
Ensure brevity in your answer.  11.56. 